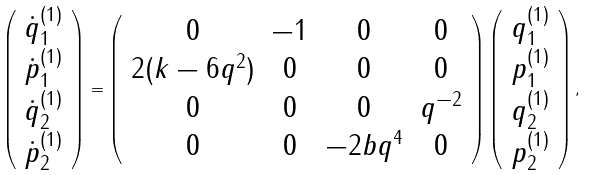<formula> <loc_0><loc_0><loc_500><loc_500>\left ( \begin{array} { c } \dot { q } _ { 1 } ^ { ( 1 ) } \\ \dot { p } _ { 1 } ^ { ( 1 ) } \\ \dot { q } _ { 2 } ^ { ( 1 ) } \\ \dot { p } _ { 2 } ^ { ( 1 ) } \end{array} \right ) = \left ( \begin{array} { c c c c } 0 & - 1 & 0 & 0 \\ 2 ( k - 6 q ^ { 2 } ) & 0 & 0 & 0 \\ 0 & 0 & 0 & q ^ { - 2 } \\ 0 & 0 & - 2 b q ^ { 4 } & 0 \end{array} \right ) \left ( \begin{array} { c } q _ { 1 } ^ { ( 1 ) } \\ p _ { 1 } ^ { ( 1 ) } \\ q _ { 2 } ^ { ( 1 ) } \\ p _ { 2 } ^ { ( 1 ) } \end{array} \right ) ,</formula> 